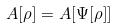<formula> <loc_0><loc_0><loc_500><loc_500>A [ \rho ] = A [ \Psi [ \rho ] ]</formula> 